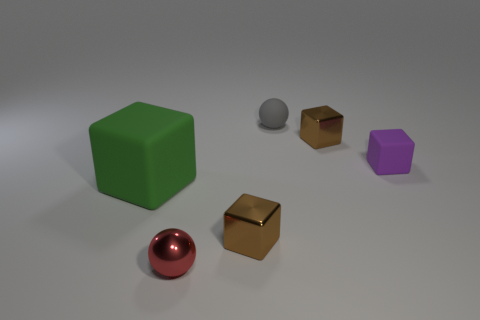If the objects were placed in order of size, what would that sequence look like? If we were to arrange the objects based on size from largest to smallest, the sequence would start with the large green cube, followed by the purple pentagonal prism. Next would be the shiny red sphere, then the two small golden cubes, which are of similar size, and finally, the small gray sphere. 